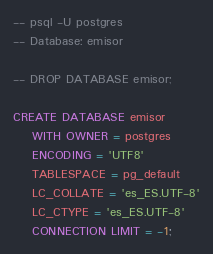Convert code to text. <code><loc_0><loc_0><loc_500><loc_500><_SQL_>-- psql -U postgres
-- Database: emisor

-- DROP DATABASE emisor;

CREATE DATABASE emisor
    WITH OWNER = postgres
    ENCODING = 'UTF8'
    TABLESPACE = pg_default
    LC_COLLATE = 'es_ES.UTF-8'
    LC_CTYPE = 'es_ES.UTF-8'
    CONNECTION LIMIT = -1;
</code> 